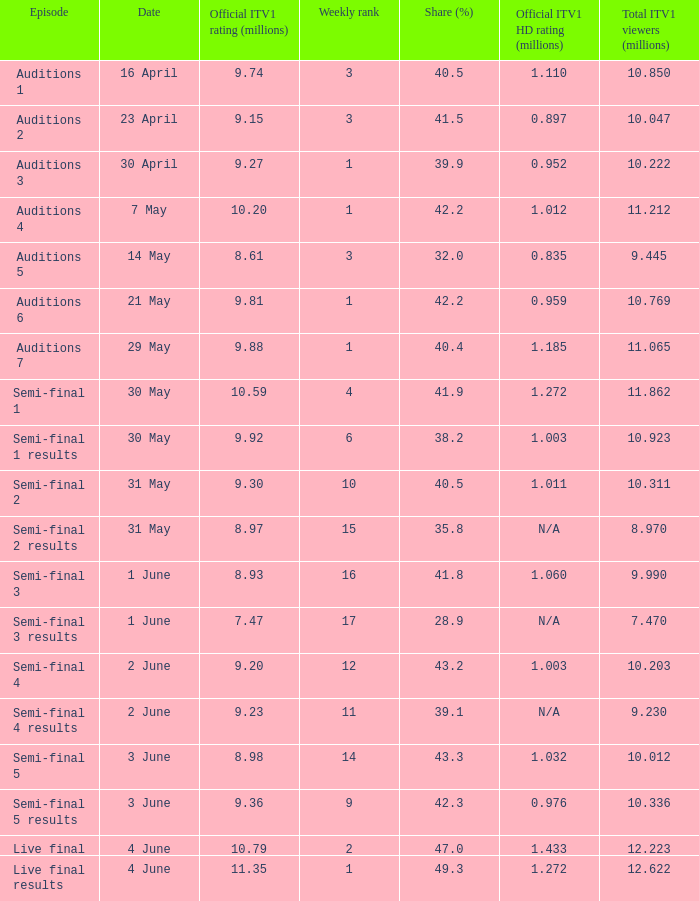What was the percentage share for the episode semi-final 2? 40.5. 